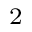<formula> <loc_0><loc_0><loc_500><loc_500>_ { 2 }</formula> 